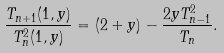<formula> <loc_0><loc_0><loc_500><loc_500>\frac { T _ { n + 1 } ( 1 , y ) } { T _ { n } ^ { 2 } ( 1 , y ) } = ( 2 + y ) - \frac { 2 y T _ { n - 1 } ^ { 2 } } { T _ { n } } .</formula> 